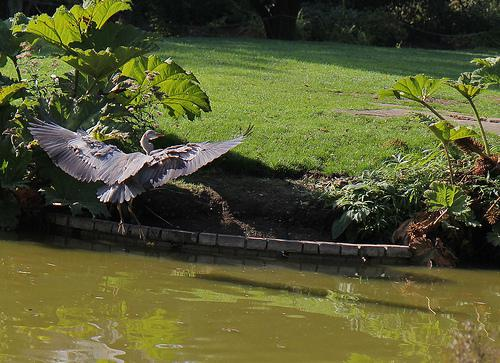Question: how is the photo?
Choices:
A. Clear.
B. Blurry.
C. Wet.
D. Faded.
Answer with the letter. Answer: A Question: why is the photo empty?
Choices:
A. Took a picture of nothing.
B. Broken camera.
C. There is noone.
D. Everyone left the area.
Answer with the letter. Answer: C 